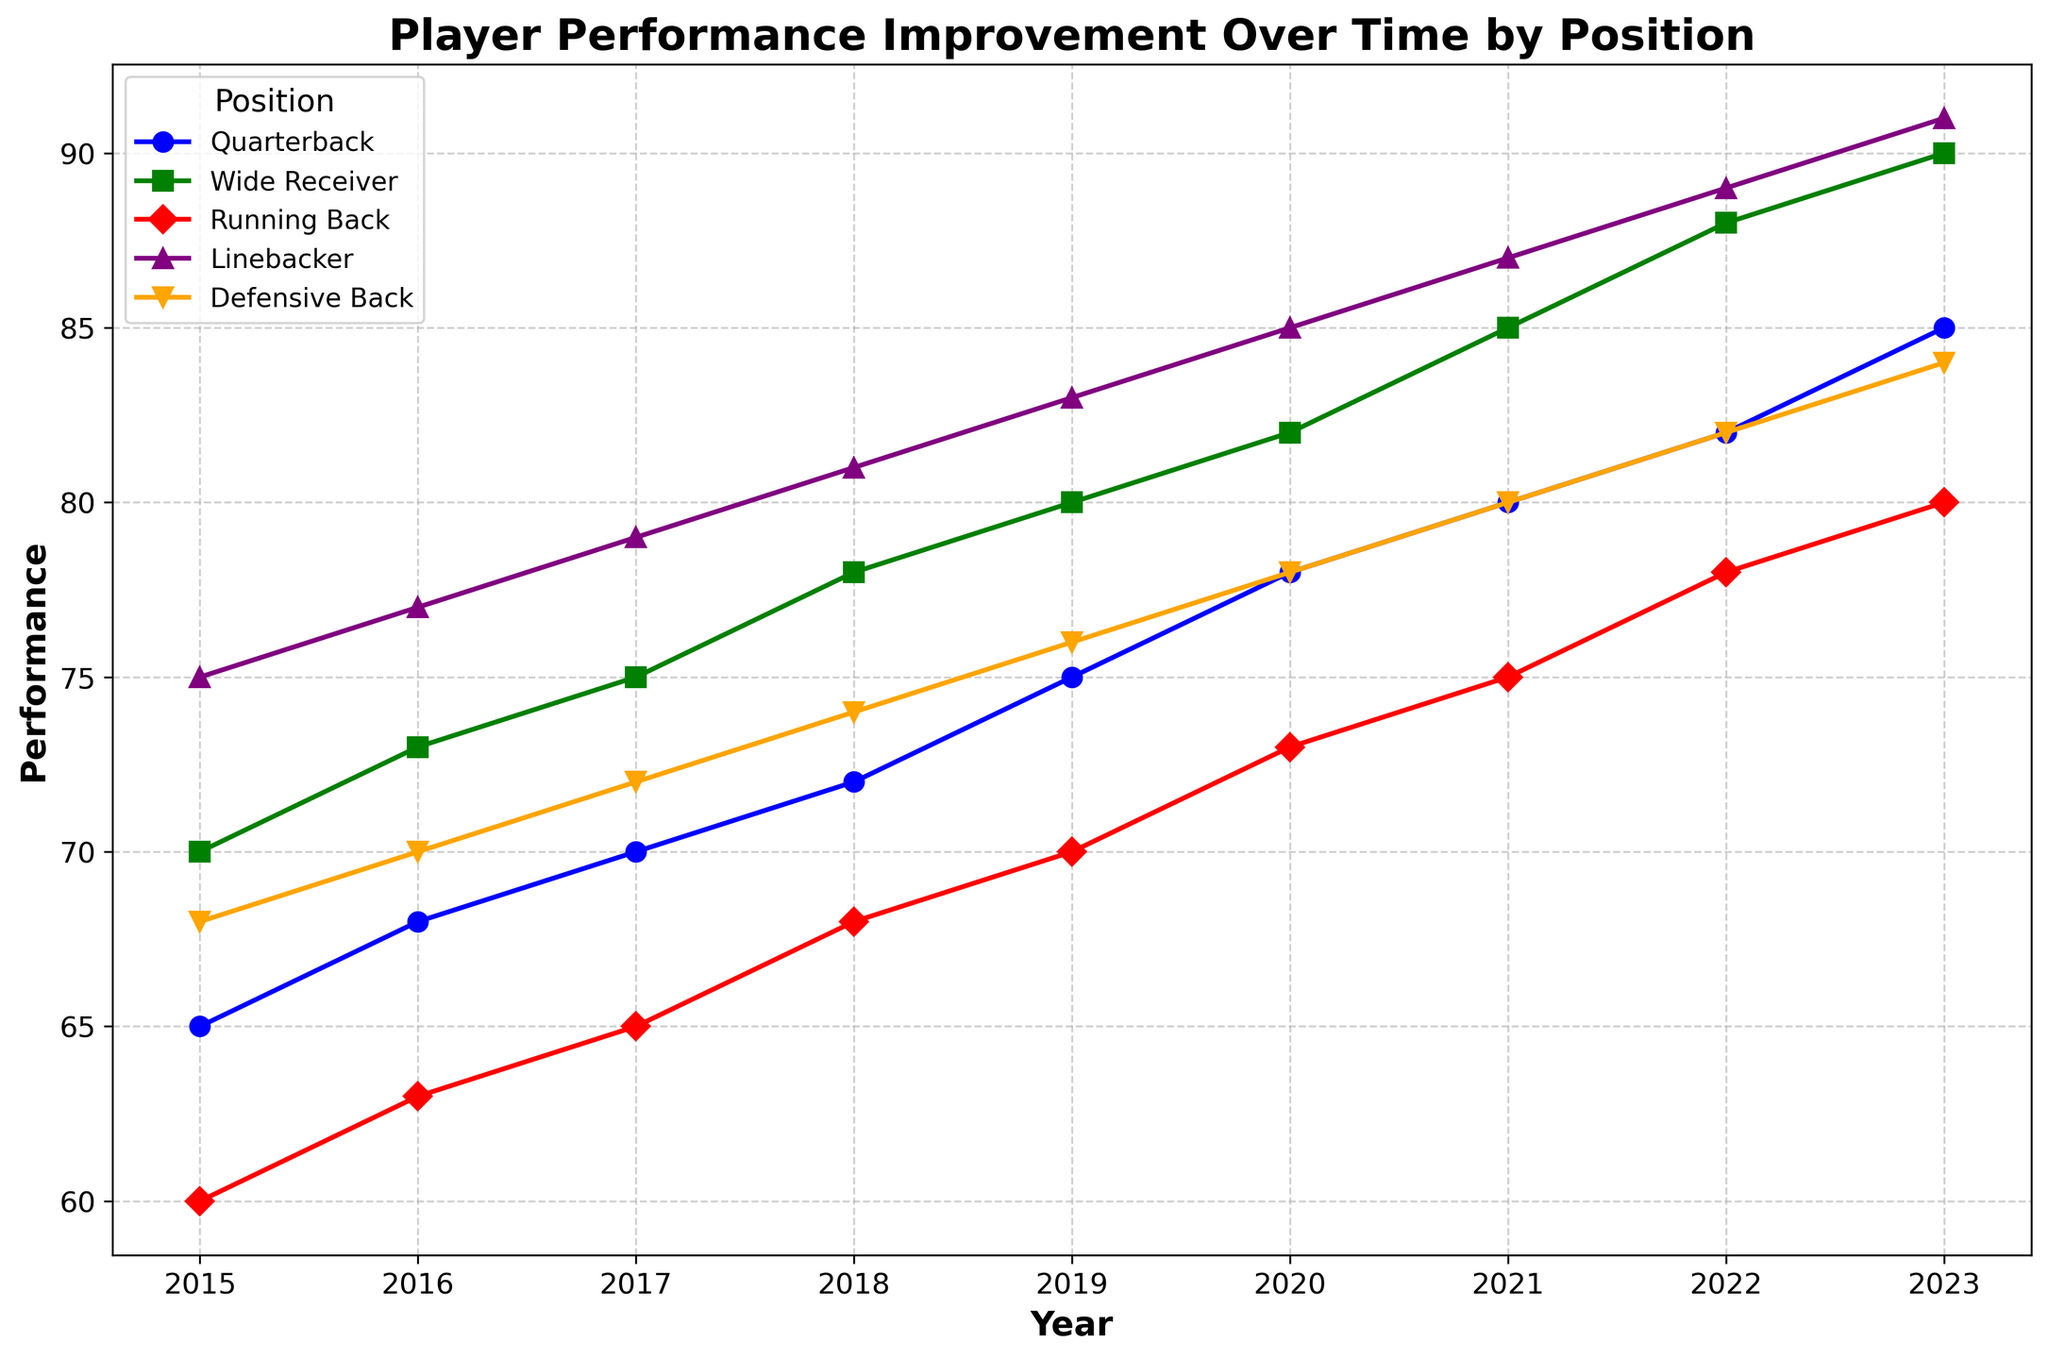Which position shows the greatest performance improvement from 2015 to 2023? Compare the performance values from 2015 to 2023 for each position. Quarterback: 85-65=20, Wide Receiver: 90-70=20, Running Back: 80-60=20, Linebacker: 91-75=16, Defensive Back: 84-68=16. Quarterback, Wide Receiver, and Running Back show the greatest improvement.
Answer: Quarterback, Wide Receiver, Running Back In which year did Linebacker performance first exceed 80? Look at the trend line for Linebacker and identify the year when its performance value first went above 80. That occurs in 2019.
Answer: 2019 Which position had the lowest performance improvement from 2015 to 2023? Compute the difference between 2015 and 2023 for each position. Differences: Quarterback: 20, Wide Receiver: 20, Running Back: 20, Linebacker: 16, Defensive Back: 16. Linebacker and Defensive Back had the lowest improvement.
Answer: Linebacker, Defensive Back What was the average performance of Quarterbacks from 2015 to 2023? Sum up the performance values of Quarterbacks for each year and divide by the number of years: (65+68+70+72+75+78+80+82+85)/9 = 737/9 ≈ 81.89
Answer: 81.89 Which positions had equal performance in 2020? Look for positions with the same performance value in 2020. The data shows that no two positions have equal performance in 2020.
Answer: None Between which years did Defensive Back performance show the greatest increase? Compute the difference in performance for each consecutive year: 2023-2022: 2, 2022-2021: 2, 2021-2020: 2, 2020-2019: 2, 2019-2018: 2, 2018-2017: 2, 2017-2016: 2, 2016-2015: 2. The greatest increase is 2, which occurs equally each year.
Answer: 2018 to 2019, 2019 to 2020, etc Which position had the most consistent performance improvement over the years? A line with a smooth, steady rise indicates consistent improvement. Comparing the lines, Defensive Back shows the most consistent, linear improvement.
Answer: Defensive Back 